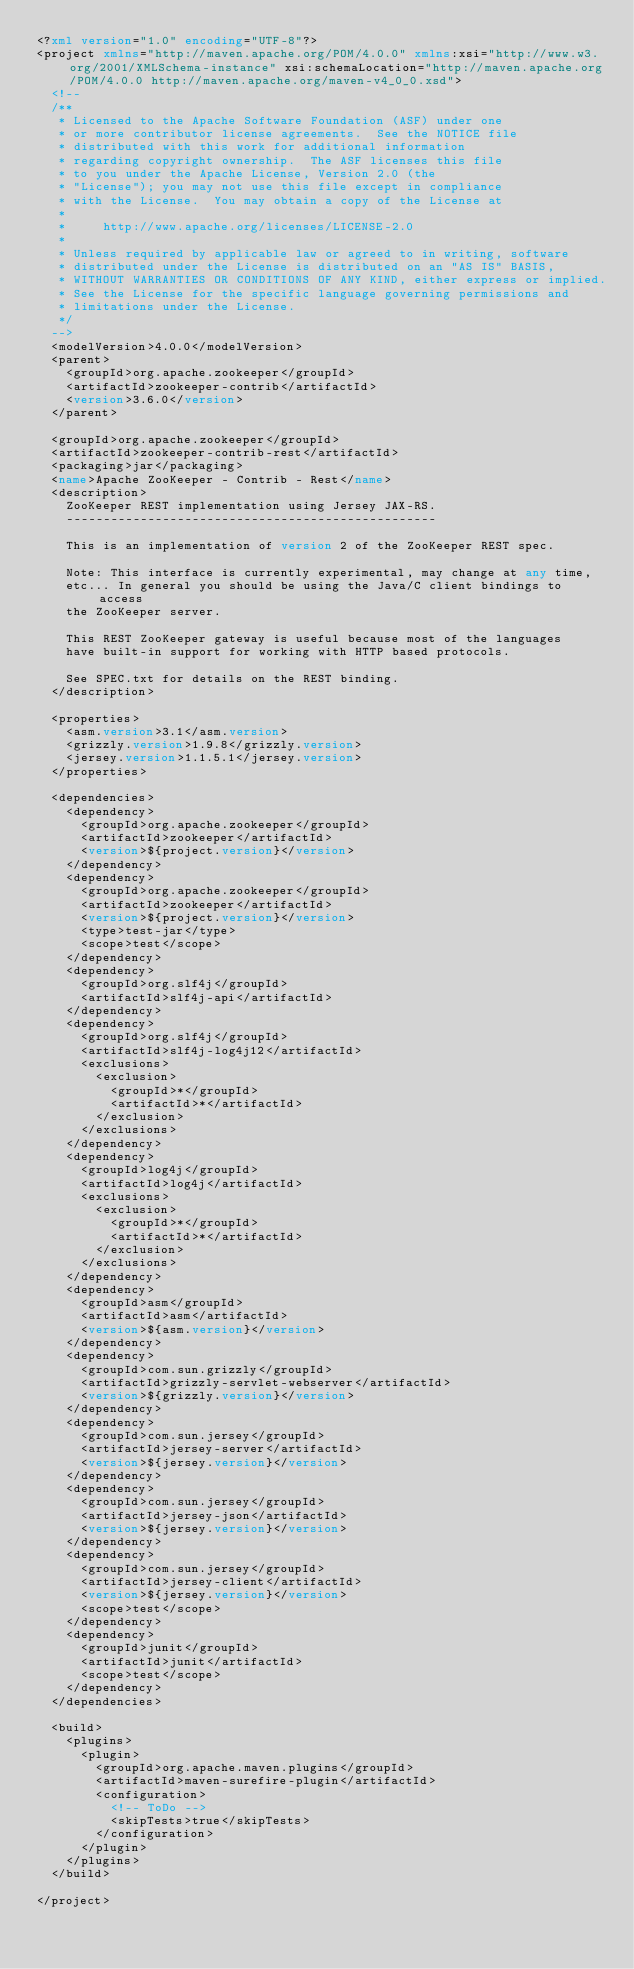Convert code to text. <code><loc_0><loc_0><loc_500><loc_500><_XML_><?xml version="1.0" encoding="UTF-8"?>
<project xmlns="http://maven.apache.org/POM/4.0.0" xmlns:xsi="http://www.w3.org/2001/XMLSchema-instance" xsi:schemaLocation="http://maven.apache.org/POM/4.0.0 http://maven.apache.org/maven-v4_0_0.xsd">
  <!--
  /**
   * Licensed to the Apache Software Foundation (ASF) under one
   * or more contributor license agreements.  See the NOTICE file
   * distributed with this work for additional information
   * regarding copyright ownership.  The ASF licenses this file
   * to you under the Apache License, Version 2.0 (the
   * "License"); you may not use this file except in compliance
   * with the License.  You may obtain a copy of the License at
   *
   *     http://www.apache.org/licenses/LICENSE-2.0
   *
   * Unless required by applicable law or agreed to in writing, software
   * distributed under the License is distributed on an "AS IS" BASIS,
   * WITHOUT WARRANTIES OR CONDITIONS OF ANY KIND, either express or implied.
   * See the License for the specific language governing permissions and
   * limitations under the License.
   */
  -->
  <modelVersion>4.0.0</modelVersion>
  <parent>
    <groupId>org.apache.zookeeper</groupId>
    <artifactId>zookeeper-contrib</artifactId>
    <version>3.6.0</version>
  </parent>

  <groupId>org.apache.zookeeper</groupId>
  <artifactId>zookeeper-contrib-rest</artifactId>
  <packaging>jar</packaging>
  <name>Apache ZooKeeper - Contrib - Rest</name>
  <description>
    ZooKeeper REST implementation using Jersey JAX-RS.
    --------------------------------------------------

    This is an implementation of version 2 of the ZooKeeper REST spec.

    Note: This interface is currently experimental, may change at any time,
    etc... In general you should be using the Java/C client bindings to access
    the ZooKeeper server.

    This REST ZooKeeper gateway is useful because most of the languages
    have built-in support for working with HTTP based protocols.

    See SPEC.txt for details on the REST binding.
  </description>

  <properties>
    <asm.version>3.1</asm.version>
    <grizzly.version>1.9.8</grizzly.version>
    <jersey.version>1.1.5.1</jersey.version>
  </properties>

  <dependencies>
    <dependency>
      <groupId>org.apache.zookeeper</groupId>
      <artifactId>zookeeper</artifactId>
      <version>${project.version}</version>
    </dependency>
    <dependency>
      <groupId>org.apache.zookeeper</groupId>
      <artifactId>zookeeper</artifactId>
      <version>${project.version}</version>
      <type>test-jar</type>
      <scope>test</scope>
    </dependency>
    <dependency>
      <groupId>org.slf4j</groupId>
      <artifactId>slf4j-api</artifactId>
    </dependency>
    <dependency>
      <groupId>org.slf4j</groupId>
      <artifactId>slf4j-log4j12</artifactId>
      <exclusions>
        <exclusion>
          <groupId>*</groupId>
          <artifactId>*</artifactId>
        </exclusion>
      </exclusions>
    </dependency>
    <dependency>
      <groupId>log4j</groupId>
      <artifactId>log4j</artifactId>
      <exclusions>
        <exclusion>
          <groupId>*</groupId>
          <artifactId>*</artifactId>
        </exclusion>
      </exclusions>
    </dependency>
    <dependency>
      <groupId>asm</groupId>
      <artifactId>asm</artifactId>
      <version>${asm.version}</version>
    </dependency>
    <dependency>
      <groupId>com.sun.grizzly</groupId>
      <artifactId>grizzly-servlet-webserver</artifactId>
      <version>${grizzly.version}</version>
    </dependency>
    <dependency>
      <groupId>com.sun.jersey</groupId>
      <artifactId>jersey-server</artifactId>
      <version>${jersey.version}</version>
    </dependency>
    <dependency>
      <groupId>com.sun.jersey</groupId>
      <artifactId>jersey-json</artifactId>
      <version>${jersey.version}</version>
    </dependency>
    <dependency>
      <groupId>com.sun.jersey</groupId>
      <artifactId>jersey-client</artifactId>
      <version>${jersey.version}</version>
      <scope>test</scope>
    </dependency>
    <dependency>
      <groupId>junit</groupId>
      <artifactId>junit</artifactId>
      <scope>test</scope>
    </dependency>
  </dependencies>

  <build>
    <plugins>
      <plugin>
        <groupId>org.apache.maven.plugins</groupId>
        <artifactId>maven-surefire-plugin</artifactId>
        <configuration>
          <!-- ToDo -->
          <skipTests>true</skipTests>
        </configuration>
      </plugin>
    </plugins>
  </build>

</project></code> 